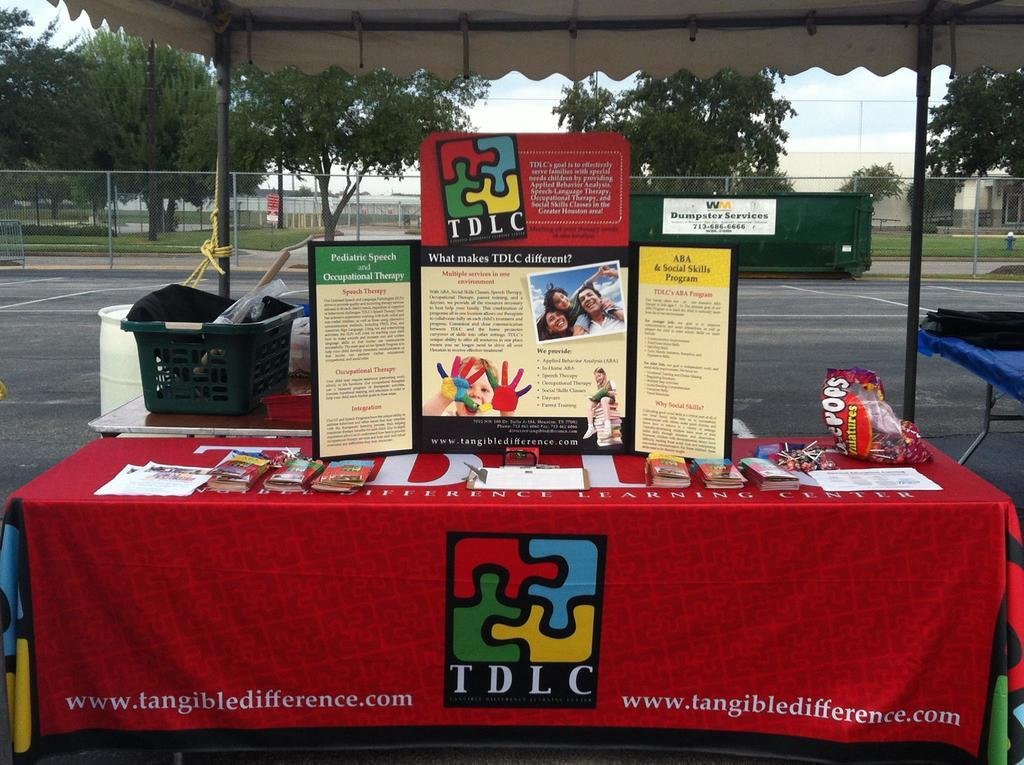<image>
Present a compact description of the photo's key features. A display table with TDLC written on the front of it. 